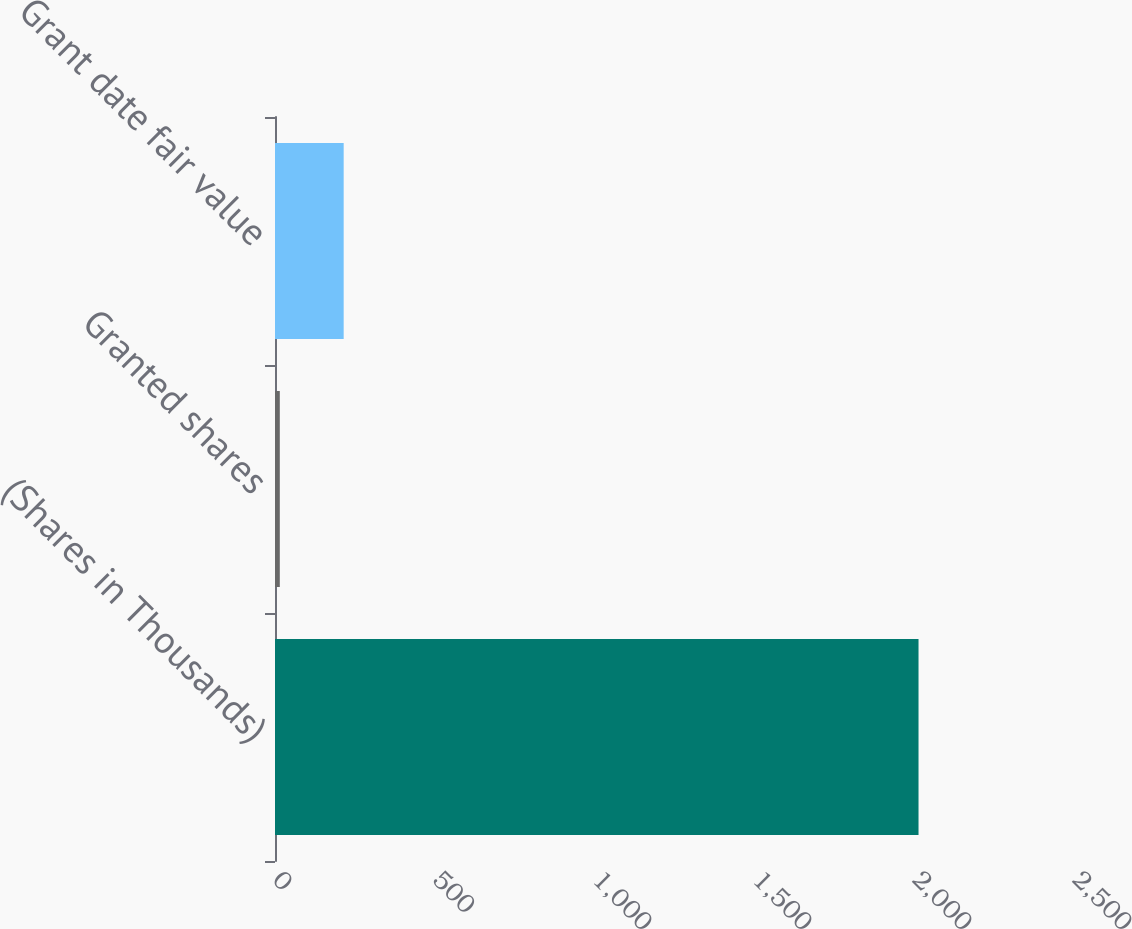Convert chart. <chart><loc_0><loc_0><loc_500><loc_500><bar_chart><fcel>(Shares in Thousands)<fcel>Granted shares<fcel>Grant date fair value<nl><fcel>2011<fcel>15<fcel>214.6<nl></chart> 